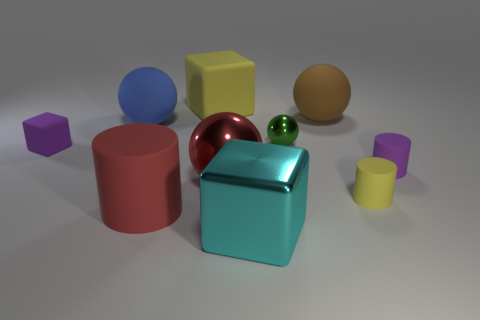Subtract all cyan balls. Subtract all red blocks. How many balls are left? 4 Subtract all cylinders. How many objects are left? 7 Add 5 blue balls. How many blue balls are left? 6 Add 1 large blue matte cubes. How many large blue matte cubes exist? 1 Subtract 0 brown cylinders. How many objects are left? 10 Subtract all green shiny things. Subtract all cyan objects. How many objects are left? 8 